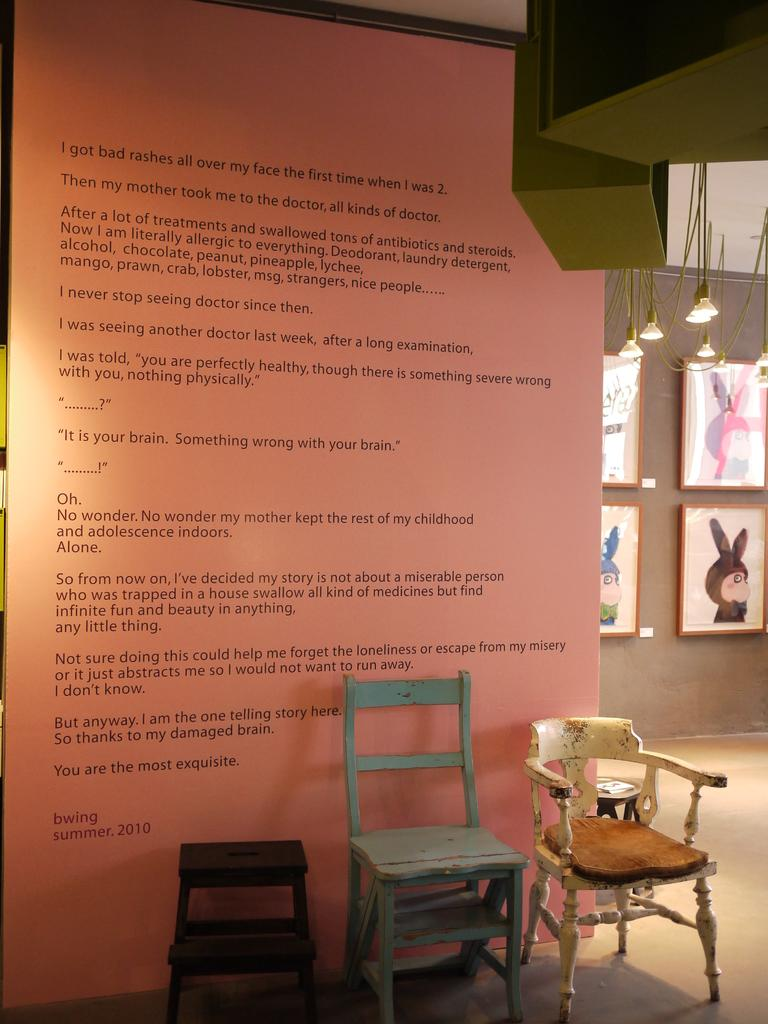What can be seen on the wall in the image? There is text on the wall in the image. How many chairs are in front of the wall? There are 3 chairs in front of the wall. What is located on the right side of the wall? There are photo frames on the right side of the wall. What is hanging from the ceiling in the image? Lights are hanging from the ceiling. What type of cabbage is growing on the wall in the image? There is no cabbage present in the image; it features text on the wall, chairs, photo frames, and hanging lights. How many wheels can be seen on the chairs in the image? The chairs in the image do not have wheels; they are stationary. 